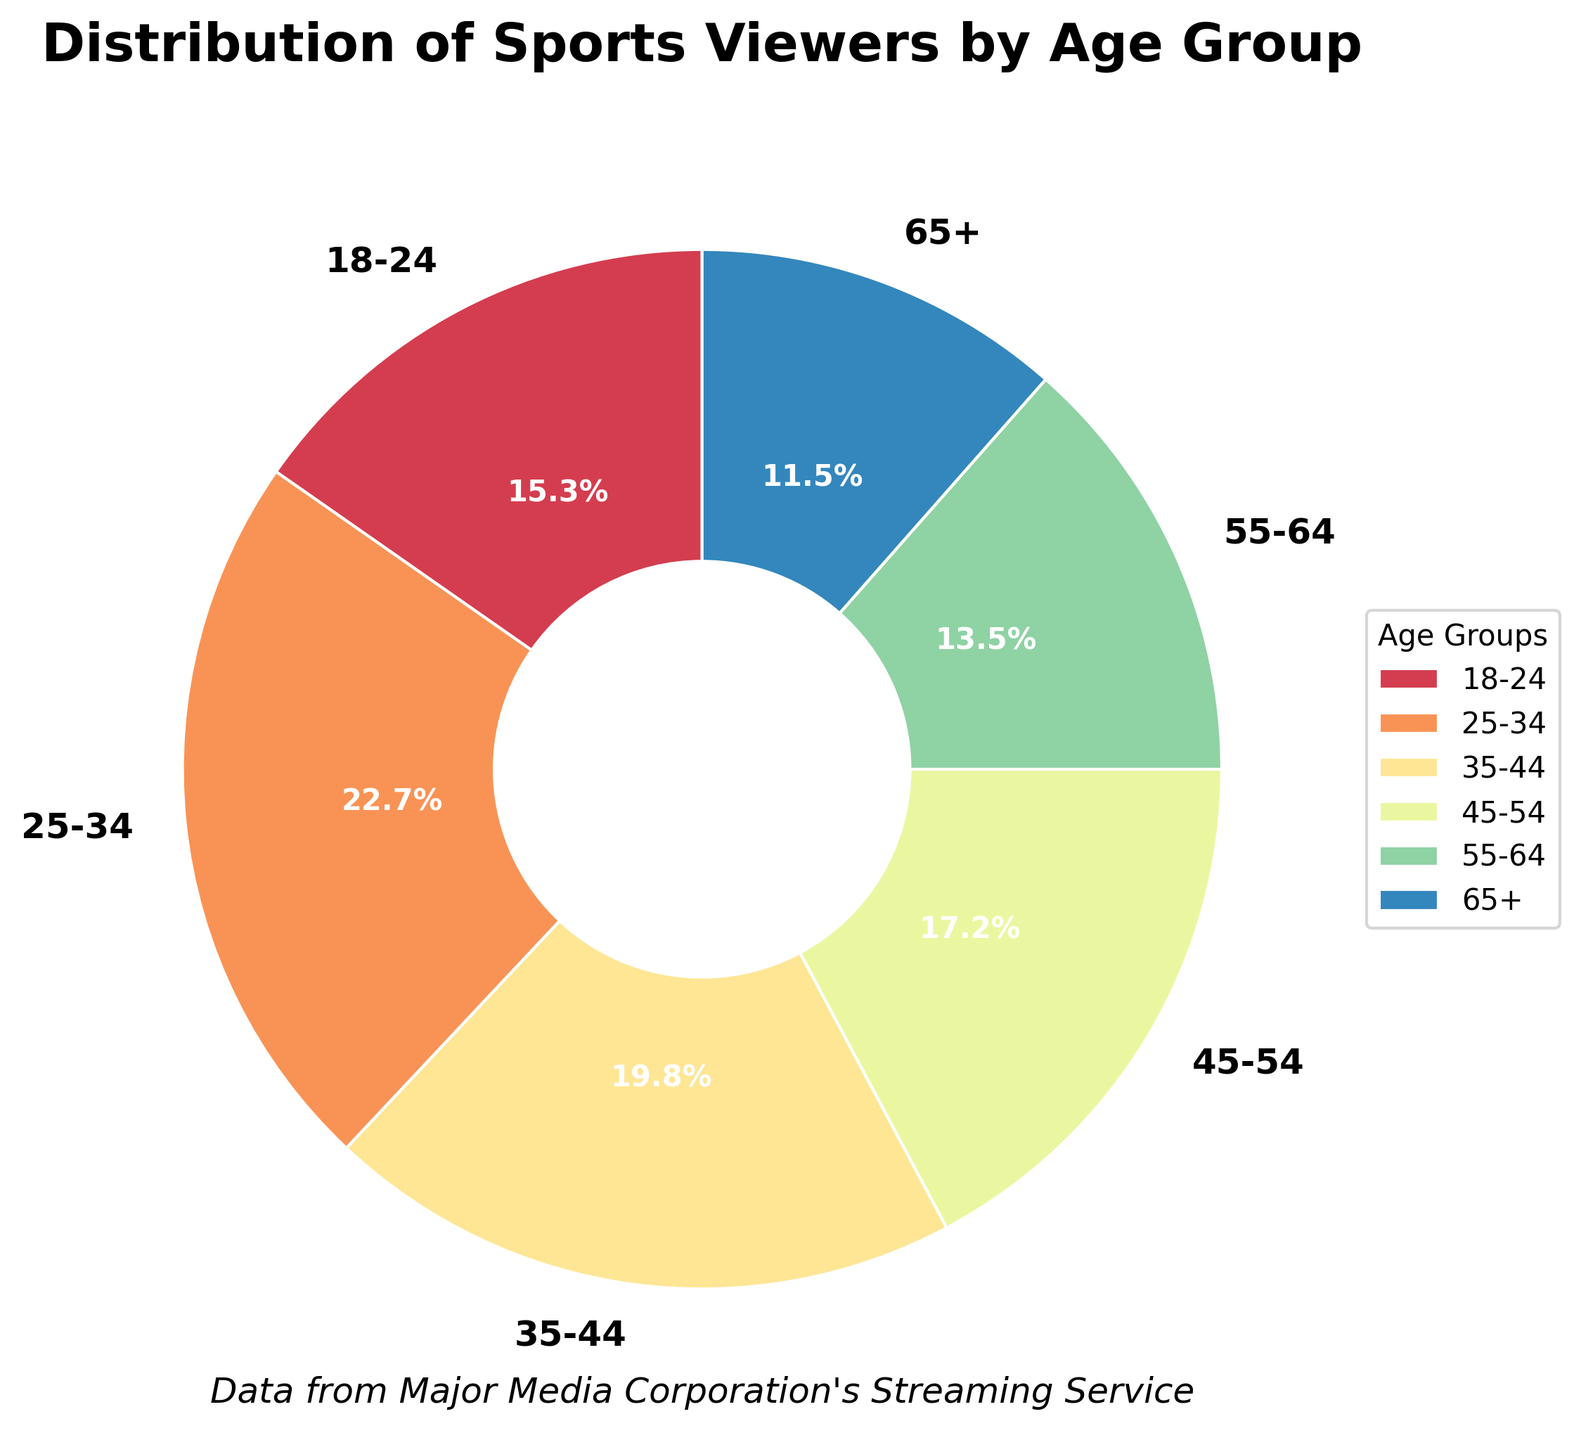What's the largest age group watching sports? From the pie chart, we see the segment with the highest percentage. The largest segment is for the 25-34 age group which accounts for 22.7% of the viewers.
Answer: 25-34 Which age group has the smallest share of viewers? The smallest segment on the pie chart is for the 65+ age group, which accounts for 11.5% of the viewers.
Answer: 65+ What is the combined percentage of viewers aged 18-24 and 25-34? To find the combined percentage, add the values for both age groups: 15.3% (18-24) + 22.7% (25-34) = 38.0%.
Answer: 38.0% How do the percentages of viewers aged 45-54 compare to those aged 55-64? Viewers aged 45-54 account for 17.2% of the total, while those aged 55-64 account for 13.5%. Comparing the two, 17.2% is greater than 13.5%.
Answer: 17.2% is greater Which age group segment uses the darkest color in the pie chart? The pie chart uses a color palette where darker colors are more prominent. The darkest segment represents the 25-34 age group, which also happens to be the largest segment.
Answer: 25-34 What is the average percentage of viewers across all age groups? To find the average, sum the percentages of all age groups and divide by the number of groups: (15.3 + 22.7 + 19.8 + 17.2 + 13.5 + 11.5) / 6 = 100 / 6 = 16.67%.
Answer: 16.67% How much larger is the percentage of viewers aged 25-34 compared to 65+? The difference between the two percentages is: 22.7% (25-34) - 11.5% (65+) = 11.2%.
Answer: 11.2% Which two age groups combined make up over 40% of the viewers? Adding the largest two segments: 22.7% (25-34) and 19.8% (35-44), we get 22.7 + 19.8 = 42.5%, which is over 40%.
Answer: 25-34 and 35-44 What's the difference in the percentage of viewers between the 18-24 and 45-54 age groups? Subtract the percentage of viewers aged 18-24 from those aged 45-54: 17.2% (45-54) - 15.3% (18-24) = 1.9%.
Answer: 1.9% What percentage of the viewers are 35 years old or older? Combine the percentages from age groups 35-44, 45-54, 55-64, and 65+: 19.8 + 17.2 + 13.5 + 11.5 = 62.0%.
Answer: 62.0% 